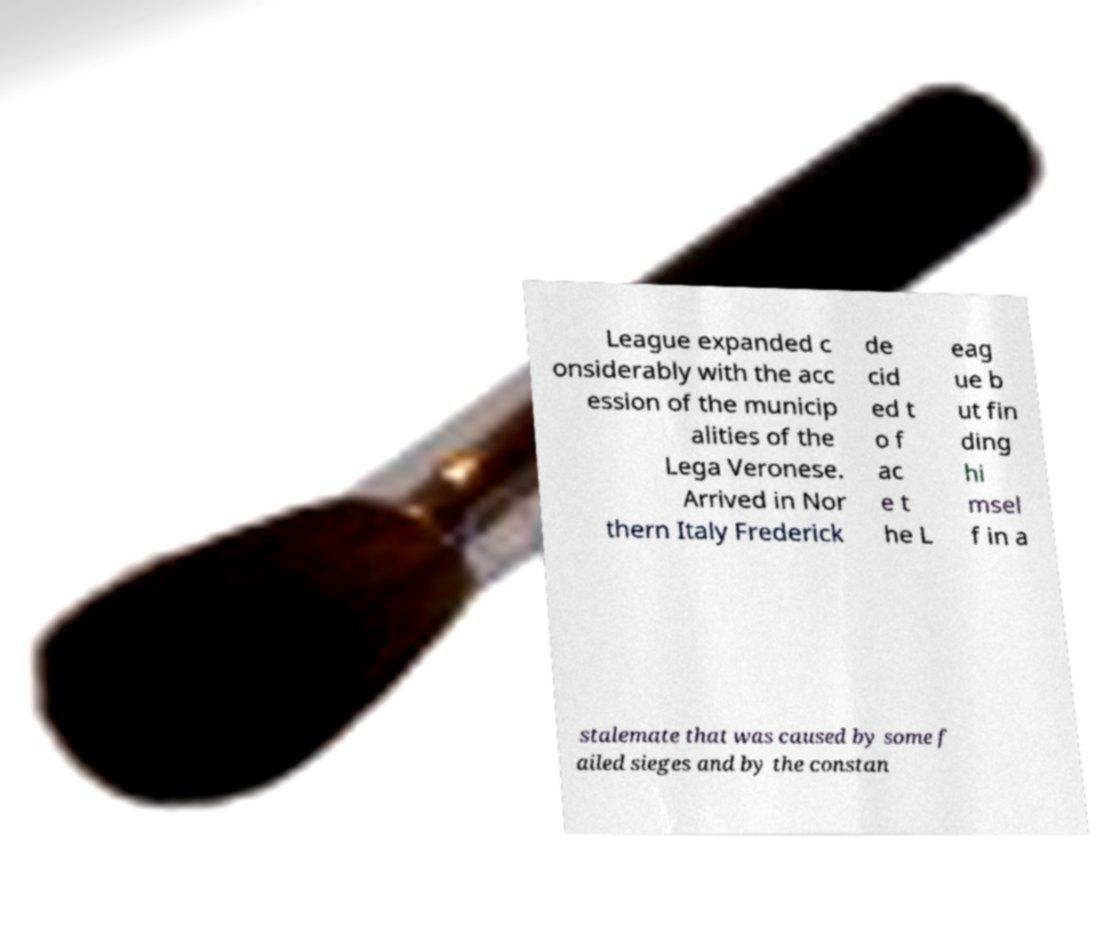What messages or text are displayed in this image? I need them in a readable, typed format. League expanded c onsiderably with the acc ession of the municip alities of the Lega Veronese. Arrived in Nor thern Italy Frederick de cid ed t o f ac e t he L eag ue b ut fin ding hi msel f in a stalemate that was caused by some f ailed sieges and by the constan 